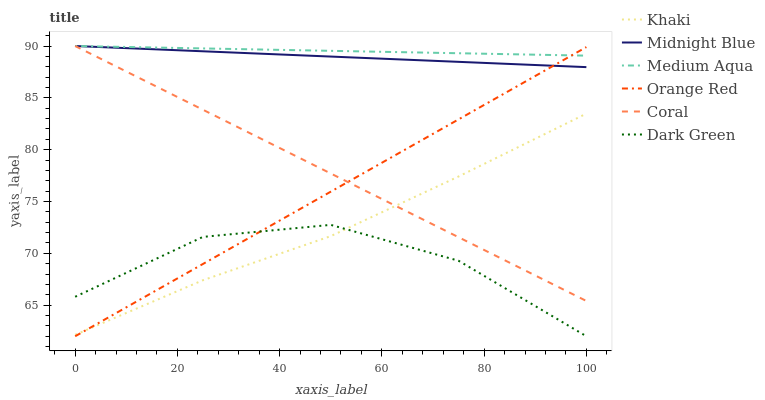Does Dark Green have the minimum area under the curve?
Answer yes or no. Yes. Does Medium Aqua have the maximum area under the curve?
Answer yes or no. Yes. Does Midnight Blue have the minimum area under the curve?
Answer yes or no. No. Does Midnight Blue have the maximum area under the curve?
Answer yes or no. No. Is Midnight Blue the smoothest?
Answer yes or no. Yes. Is Dark Green the roughest?
Answer yes or no. Yes. Is Coral the smoothest?
Answer yes or no. No. Is Coral the roughest?
Answer yes or no. No. Does Midnight Blue have the lowest value?
Answer yes or no. No. Does Medium Aqua have the highest value?
Answer yes or no. Yes. Does Orange Red have the highest value?
Answer yes or no. No. Is Dark Green less than Coral?
Answer yes or no. Yes. Is Coral greater than Dark Green?
Answer yes or no. Yes. Does Coral intersect Midnight Blue?
Answer yes or no. Yes. Is Coral less than Midnight Blue?
Answer yes or no. No. Is Coral greater than Midnight Blue?
Answer yes or no. No. Does Dark Green intersect Coral?
Answer yes or no. No. 